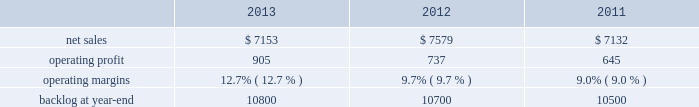Mfc 2019s operating profit for 2013 increased $ 175 million , or 14% ( 14 % ) , compared to 2012 .
The increase was primarily attributable to higher operating profit of approximately $ 85 million for air and missile defense programs ( thaad and pac-3 ) due to increased risk retirements and volume ; about $ 85 million for fire control programs ( sniper ae , lantirn ae and apache ) due to increased risk retirements and higher volume ; and approximately $ 75 million for tactical missile programs ( hellfire and various programs ) due to increased risk retirements .
The increases were partially offset by lower operating profit of about $ 45 million for the resolution of contractual matters in the second quarter of 2012 ; and approximately $ 15 million for various technical services programs due to lower volume partially offset by increased risk retirements .
Adjustments not related to volume , including net profit booking rate adjustments and other matters , were approximately $ 100 million higher for 2013 compared to 2012 .
2012 compared to 2011 mfc 2019s net sales for 2012 were comparable to 2011 .
Net sales decreased approximately $ 130 million due to lower volume and risk retirements on various services programs , and about $ 60 million due to lower volume from fire control systems programs ( primarily sniper ae ; lantirn ae ; and apache ) .
The decreases largely were offset by higher net sales of approximately $ 95 million due to higher volume from tactical missile programs ( primarily javelin and hellfire ) and approximately $ 80 million for air and missile defense programs ( primarily pac-3 and thaad ) .
Mfc 2019s operating profit for 2012 increased $ 187 million , or 17% ( 17 % ) , compared to 2011 .
The increase was attributable to higher risk retirements and volume of about $ 95 million from tactical missile programs ( primarily javelin and hellfire ) ; increased risk retirements and volume of approximately $ 60 million for air and missile defense programs ( primarily thaad and pac-3 ) ; and about $ 45 million from a resolution of contractual matters .
Partially offsetting these increases was lower risk retirements and volume on various programs , including $ 25 million for services programs .
Adjustments not related to volume , including net profit booking rate adjustments and other matters described above , were approximately $ 145 million higher for 2012 compared to 2011 .
Backlog backlog increased in 2013 compared to 2012 mainly due to higher orders on the thaad program and lower sales volume compared to new orders on certain fire control systems programs in 2013 , partially offset by lower orders on technical services programs and certain tactical missile programs .
Backlog increased in 2012 compared to 2011 mainly due to increased orders and lower sales on fire control systems programs ( primarily lantirn ae and sniper ae ) and on various services programs , partially offset by lower orders and higher sales volume on tactical missiles programs .
Trends we expect mfc 2019s net sales to be flat to slightly down in 2014 compared to 2013 , primarily due to a decrease in net sales on technical services programs partially offset by an increase in net sales from missiles and fire control programs .
Operating profit is expected to decrease in the high single digit percentage range , driven by a reduction in expected risk retirements in 2014 .
Accordingly , operating profit margin is expected to slightly decline from 2013 .
Mission systems and training our mst business segment provides ship and submarine mission and combat systems ; mission systems and sensors for rotary and fixed-wing aircraft ; sea and land-based missile defense systems ; radar systems ; littoral combat ships ; simulation and training services ; and unmanned systems and technologies .
Mst 2019s major programs include aegis combat system ( aegis ) , lcs , mh-60 , tpq-53 radar system , and mk-41 vertical launching system ( vls ) .
Mst 2019s operating results included the following ( in millions ) : .
2013 compared to 2012 mst 2019s net sales for 2013 decreased $ 426 million , or 6% ( 6 % ) , compared to 2012 .
The decrease was primarily attributable to lower net sales of approximately $ 275 million for various ship and aviation systems programs due to lower volume .
What were average operating profit from 2011 to 2013 for mst in millions? 
Computations: table_average(operating profit, none)
Answer: 762.33333. Mfc 2019s operating profit for 2013 increased $ 175 million , or 14% ( 14 % ) , compared to 2012 .
The increase was primarily attributable to higher operating profit of approximately $ 85 million for air and missile defense programs ( thaad and pac-3 ) due to increased risk retirements and volume ; about $ 85 million for fire control programs ( sniper ae , lantirn ae and apache ) due to increased risk retirements and higher volume ; and approximately $ 75 million for tactical missile programs ( hellfire and various programs ) due to increased risk retirements .
The increases were partially offset by lower operating profit of about $ 45 million for the resolution of contractual matters in the second quarter of 2012 ; and approximately $ 15 million for various technical services programs due to lower volume partially offset by increased risk retirements .
Adjustments not related to volume , including net profit booking rate adjustments and other matters , were approximately $ 100 million higher for 2013 compared to 2012 .
2012 compared to 2011 mfc 2019s net sales for 2012 were comparable to 2011 .
Net sales decreased approximately $ 130 million due to lower volume and risk retirements on various services programs , and about $ 60 million due to lower volume from fire control systems programs ( primarily sniper ae ; lantirn ae ; and apache ) .
The decreases largely were offset by higher net sales of approximately $ 95 million due to higher volume from tactical missile programs ( primarily javelin and hellfire ) and approximately $ 80 million for air and missile defense programs ( primarily pac-3 and thaad ) .
Mfc 2019s operating profit for 2012 increased $ 187 million , or 17% ( 17 % ) , compared to 2011 .
The increase was attributable to higher risk retirements and volume of about $ 95 million from tactical missile programs ( primarily javelin and hellfire ) ; increased risk retirements and volume of approximately $ 60 million for air and missile defense programs ( primarily thaad and pac-3 ) ; and about $ 45 million from a resolution of contractual matters .
Partially offsetting these increases was lower risk retirements and volume on various programs , including $ 25 million for services programs .
Adjustments not related to volume , including net profit booking rate adjustments and other matters described above , were approximately $ 145 million higher for 2012 compared to 2011 .
Backlog backlog increased in 2013 compared to 2012 mainly due to higher orders on the thaad program and lower sales volume compared to new orders on certain fire control systems programs in 2013 , partially offset by lower orders on technical services programs and certain tactical missile programs .
Backlog increased in 2012 compared to 2011 mainly due to increased orders and lower sales on fire control systems programs ( primarily lantirn ae and sniper ae ) and on various services programs , partially offset by lower orders and higher sales volume on tactical missiles programs .
Trends we expect mfc 2019s net sales to be flat to slightly down in 2014 compared to 2013 , primarily due to a decrease in net sales on technical services programs partially offset by an increase in net sales from missiles and fire control programs .
Operating profit is expected to decrease in the high single digit percentage range , driven by a reduction in expected risk retirements in 2014 .
Accordingly , operating profit margin is expected to slightly decline from 2013 .
Mission systems and training our mst business segment provides ship and submarine mission and combat systems ; mission systems and sensors for rotary and fixed-wing aircraft ; sea and land-based missile defense systems ; radar systems ; littoral combat ships ; simulation and training services ; and unmanned systems and technologies .
Mst 2019s major programs include aegis combat system ( aegis ) , lcs , mh-60 , tpq-53 radar system , and mk-41 vertical launching system ( vls ) .
Mst 2019s operating results included the following ( in millions ) : .
2013 compared to 2012 mst 2019s net sales for 2013 decreased $ 426 million , or 6% ( 6 % ) , compared to 2012 .
The decrease was primarily attributable to lower net sales of approximately $ 275 million for various ship and aviation systems programs due to lower volume .
What was the average operating profit from 2011 to 2013 in millions? 
Computations: (((905 + 737) + 645) / 3)
Answer: 762.33333. 